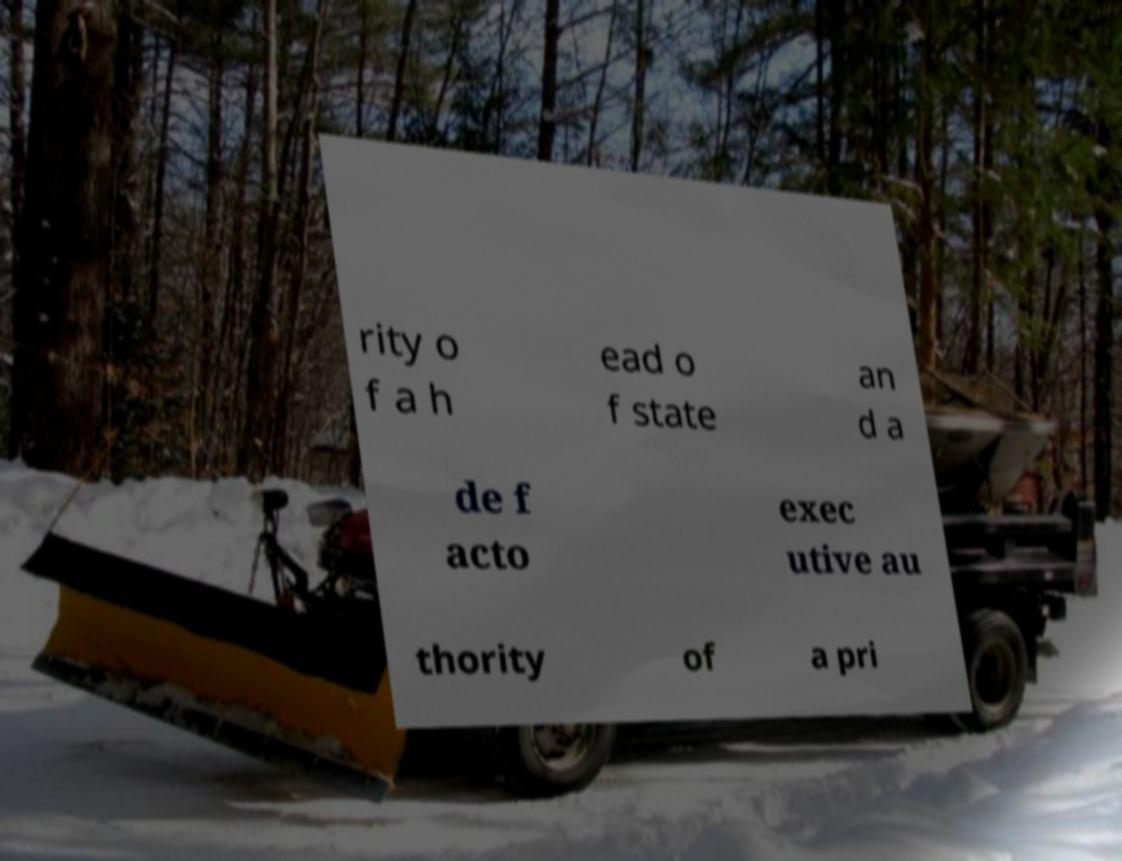What messages or text are displayed in this image? I need them in a readable, typed format. rity o f a h ead o f state an d a de f acto exec utive au thority of a pri 